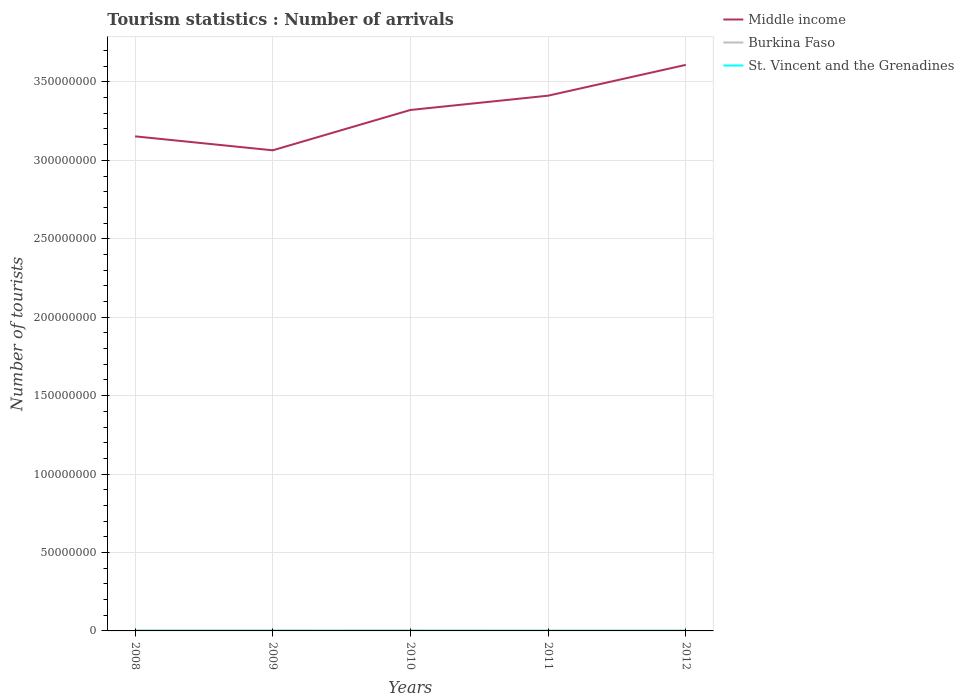Across all years, what is the maximum number of tourist arrivals in Burkina Faso?
Offer a very short reply. 2.37e+05. What is the total number of tourist arrivals in St. Vincent and the Grenadines in the graph?
Your response must be concise. 3000. What is the difference between the highest and the second highest number of tourist arrivals in St. Vincent and the Grenadines?
Offer a very short reply. 1.20e+04. Is the number of tourist arrivals in Middle income strictly greater than the number of tourist arrivals in St. Vincent and the Grenadines over the years?
Give a very brief answer. No. How many lines are there?
Your answer should be very brief. 3. How many years are there in the graph?
Your answer should be very brief. 5. What is the difference between two consecutive major ticks on the Y-axis?
Your answer should be very brief. 5.00e+07. Are the values on the major ticks of Y-axis written in scientific E-notation?
Give a very brief answer. No. Does the graph contain any zero values?
Your answer should be compact. No. What is the title of the graph?
Offer a terse response. Tourism statistics : Number of arrivals. Does "Australia" appear as one of the legend labels in the graph?
Make the answer very short. No. What is the label or title of the X-axis?
Offer a very short reply. Years. What is the label or title of the Y-axis?
Keep it short and to the point. Number of tourists. What is the Number of tourists in Middle income in 2008?
Your answer should be very brief. 3.15e+08. What is the Number of tourists in Burkina Faso in 2008?
Your answer should be very brief. 2.72e+05. What is the Number of tourists of St. Vincent and the Grenadines in 2008?
Make the answer very short. 8.40e+04. What is the Number of tourists of Middle income in 2009?
Provide a short and direct response. 3.06e+08. What is the Number of tourists in Burkina Faso in 2009?
Your answer should be very brief. 2.69e+05. What is the Number of tourists of St. Vincent and the Grenadines in 2009?
Make the answer very short. 7.50e+04. What is the Number of tourists of Middle income in 2010?
Offer a terse response. 3.32e+08. What is the Number of tourists in Burkina Faso in 2010?
Offer a terse response. 2.74e+05. What is the Number of tourists of St. Vincent and the Grenadines in 2010?
Offer a very short reply. 7.20e+04. What is the Number of tourists in Middle income in 2011?
Ensure brevity in your answer.  3.41e+08. What is the Number of tourists in Burkina Faso in 2011?
Offer a terse response. 2.38e+05. What is the Number of tourists in St. Vincent and the Grenadines in 2011?
Your answer should be very brief. 7.40e+04. What is the Number of tourists in Middle income in 2012?
Offer a very short reply. 3.61e+08. What is the Number of tourists of Burkina Faso in 2012?
Make the answer very short. 2.37e+05. What is the Number of tourists in St. Vincent and the Grenadines in 2012?
Your answer should be very brief. 7.40e+04. Across all years, what is the maximum Number of tourists in Middle income?
Your response must be concise. 3.61e+08. Across all years, what is the maximum Number of tourists in Burkina Faso?
Provide a short and direct response. 2.74e+05. Across all years, what is the maximum Number of tourists in St. Vincent and the Grenadines?
Give a very brief answer. 8.40e+04. Across all years, what is the minimum Number of tourists of Middle income?
Provide a succinct answer. 3.06e+08. Across all years, what is the minimum Number of tourists of Burkina Faso?
Your response must be concise. 2.37e+05. Across all years, what is the minimum Number of tourists in St. Vincent and the Grenadines?
Provide a succinct answer. 7.20e+04. What is the total Number of tourists of Middle income in the graph?
Ensure brevity in your answer.  1.66e+09. What is the total Number of tourists of Burkina Faso in the graph?
Ensure brevity in your answer.  1.29e+06. What is the total Number of tourists of St. Vincent and the Grenadines in the graph?
Ensure brevity in your answer.  3.79e+05. What is the difference between the Number of tourists in Middle income in 2008 and that in 2009?
Your answer should be compact. 8.90e+06. What is the difference between the Number of tourists of Burkina Faso in 2008 and that in 2009?
Provide a succinct answer. 3000. What is the difference between the Number of tourists in St. Vincent and the Grenadines in 2008 and that in 2009?
Your answer should be very brief. 9000. What is the difference between the Number of tourists of Middle income in 2008 and that in 2010?
Your answer should be very brief. -1.68e+07. What is the difference between the Number of tourists of Burkina Faso in 2008 and that in 2010?
Offer a terse response. -2000. What is the difference between the Number of tourists of St. Vincent and the Grenadines in 2008 and that in 2010?
Your answer should be compact. 1.20e+04. What is the difference between the Number of tourists in Middle income in 2008 and that in 2011?
Your answer should be compact. -2.59e+07. What is the difference between the Number of tourists of Burkina Faso in 2008 and that in 2011?
Provide a short and direct response. 3.40e+04. What is the difference between the Number of tourists of Middle income in 2008 and that in 2012?
Keep it short and to the point. -4.56e+07. What is the difference between the Number of tourists in Burkina Faso in 2008 and that in 2012?
Offer a terse response. 3.50e+04. What is the difference between the Number of tourists in Middle income in 2009 and that in 2010?
Give a very brief answer. -2.57e+07. What is the difference between the Number of tourists of Burkina Faso in 2009 and that in 2010?
Offer a terse response. -5000. What is the difference between the Number of tourists in St. Vincent and the Grenadines in 2009 and that in 2010?
Make the answer very short. 3000. What is the difference between the Number of tourists of Middle income in 2009 and that in 2011?
Your response must be concise. -3.48e+07. What is the difference between the Number of tourists in Burkina Faso in 2009 and that in 2011?
Keep it short and to the point. 3.10e+04. What is the difference between the Number of tourists of St. Vincent and the Grenadines in 2009 and that in 2011?
Your answer should be very brief. 1000. What is the difference between the Number of tourists of Middle income in 2009 and that in 2012?
Keep it short and to the point. -5.45e+07. What is the difference between the Number of tourists of Burkina Faso in 2009 and that in 2012?
Keep it short and to the point. 3.20e+04. What is the difference between the Number of tourists in St. Vincent and the Grenadines in 2009 and that in 2012?
Give a very brief answer. 1000. What is the difference between the Number of tourists in Middle income in 2010 and that in 2011?
Keep it short and to the point. -9.11e+06. What is the difference between the Number of tourists in Burkina Faso in 2010 and that in 2011?
Offer a very short reply. 3.60e+04. What is the difference between the Number of tourists in St. Vincent and the Grenadines in 2010 and that in 2011?
Your answer should be compact. -2000. What is the difference between the Number of tourists of Middle income in 2010 and that in 2012?
Offer a very short reply. -2.88e+07. What is the difference between the Number of tourists of Burkina Faso in 2010 and that in 2012?
Give a very brief answer. 3.70e+04. What is the difference between the Number of tourists in St. Vincent and the Grenadines in 2010 and that in 2012?
Offer a terse response. -2000. What is the difference between the Number of tourists in Middle income in 2011 and that in 2012?
Offer a very short reply. -1.96e+07. What is the difference between the Number of tourists of St. Vincent and the Grenadines in 2011 and that in 2012?
Ensure brevity in your answer.  0. What is the difference between the Number of tourists of Middle income in 2008 and the Number of tourists of Burkina Faso in 2009?
Keep it short and to the point. 3.15e+08. What is the difference between the Number of tourists of Middle income in 2008 and the Number of tourists of St. Vincent and the Grenadines in 2009?
Offer a very short reply. 3.15e+08. What is the difference between the Number of tourists of Burkina Faso in 2008 and the Number of tourists of St. Vincent and the Grenadines in 2009?
Your answer should be compact. 1.97e+05. What is the difference between the Number of tourists in Middle income in 2008 and the Number of tourists in Burkina Faso in 2010?
Your answer should be compact. 3.15e+08. What is the difference between the Number of tourists in Middle income in 2008 and the Number of tourists in St. Vincent and the Grenadines in 2010?
Offer a terse response. 3.15e+08. What is the difference between the Number of tourists of Burkina Faso in 2008 and the Number of tourists of St. Vincent and the Grenadines in 2010?
Keep it short and to the point. 2.00e+05. What is the difference between the Number of tourists in Middle income in 2008 and the Number of tourists in Burkina Faso in 2011?
Your answer should be compact. 3.15e+08. What is the difference between the Number of tourists in Middle income in 2008 and the Number of tourists in St. Vincent and the Grenadines in 2011?
Make the answer very short. 3.15e+08. What is the difference between the Number of tourists of Burkina Faso in 2008 and the Number of tourists of St. Vincent and the Grenadines in 2011?
Offer a very short reply. 1.98e+05. What is the difference between the Number of tourists of Middle income in 2008 and the Number of tourists of Burkina Faso in 2012?
Your answer should be compact. 3.15e+08. What is the difference between the Number of tourists of Middle income in 2008 and the Number of tourists of St. Vincent and the Grenadines in 2012?
Make the answer very short. 3.15e+08. What is the difference between the Number of tourists in Burkina Faso in 2008 and the Number of tourists in St. Vincent and the Grenadines in 2012?
Offer a very short reply. 1.98e+05. What is the difference between the Number of tourists of Middle income in 2009 and the Number of tourists of Burkina Faso in 2010?
Provide a short and direct response. 3.06e+08. What is the difference between the Number of tourists in Middle income in 2009 and the Number of tourists in St. Vincent and the Grenadines in 2010?
Provide a succinct answer. 3.06e+08. What is the difference between the Number of tourists of Burkina Faso in 2009 and the Number of tourists of St. Vincent and the Grenadines in 2010?
Give a very brief answer. 1.97e+05. What is the difference between the Number of tourists in Middle income in 2009 and the Number of tourists in Burkina Faso in 2011?
Your answer should be very brief. 3.06e+08. What is the difference between the Number of tourists of Middle income in 2009 and the Number of tourists of St. Vincent and the Grenadines in 2011?
Your answer should be very brief. 3.06e+08. What is the difference between the Number of tourists in Burkina Faso in 2009 and the Number of tourists in St. Vincent and the Grenadines in 2011?
Provide a succinct answer. 1.95e+05. What is the difference between the Number of tourists of Middle income in 2009 and the Number of tourists of Burkina Faso in 2012?
Offer a very short reply. 3.06e+08. What is the difference between the Number of tourists in Middle income in 2009 and the Number of tourists in St. Vincent and the Grenadines in 2012?
Your response must be concise. 3.06e+08. What is the difference between the Number of tourists in Burkina Faso in 2009 and the Number of tourists in St. Vincent and the Grenadines in 2012?
Provide a short and direct response. 1.95e+05. What is the difference between the Number of tourists of Middle income in 2010 and the Number of tourists of Burkina Faso in 2011?
Your answer should be very brief. 3.32e+08. What is the difference between the Number of tourists in Middle income in 2010 and the Number of tourists in St. Vincent and the Grenadines in 2011?
Ensure brevity in your answer.  3.32e+08. What is the difference between the Number of tourists of Burkina Faso in 2010 and the Number of tourists of St. Vincent and the Grenadines in 2011?
Ensure brevity in your answer.  2.00e+05. What is the difference between the Number of tourists in Middle income in 2010 and the Number of tourists in Burkina Faso in 2012?
Ensure brevity in your answer.  3.32e+08. What is the difference between the Number of tourists in Middle income in 2010 and the Number of tourists in St. Vincent and the Grenadines in 2012?
Your answer should be very brief. 3.32e+08. What is the difference between the Number of tourists of Middle income in 2011 and the Number of tourists of Burkina Faso in 2012?
Your answer should be compact. 3.41e+08. What is the difference between the Number of tourists of Middle income in 2011 and the Number of tourists of St. Vincent and the Grenadines in 2012?
Make the answer very short. 3.41e+08. What is the difference between the Number of tourists in Burkina Faso in 2011 and the Number of tourists in St. Vincent and the Grenadines in 2012?
Make the answer very short. 1.64e+05. What is the average Number of tourists of Middle income per year?
Keep it short and to the point. 3.31e+08. What is the average Number of tourists of Burkina Faso per year?
Ensure brevity in your answer.  2.58e+05. What is the average Number of tourists of St. Vincent and the Grenadines per year?
Your answer should be very brief. 7.58e+04. In the year 2008, what is the difference between the Number of tourists in Middle income and Number of tourists in Burkina Faso?
Offer a terse response. 3.15e+08. In the year 2008, what is the difference between the Number of tourists in Middle income and Number of tourists in St. Vincent and the Grenadines?
Keep it short and to the point. 3.15e+08. In the year 2008, what is the difference between the Number of tourists in Burkina Faso and Number of tourists in St. Vincent and the Grenadines?
Your answer should be very brief. 1.88e+05. In the year 2009, what is the difference between the Number of tourists in Middle income and Number of tourists in Burkina Faso?
Your answer should be compact. 3.06e+08. In the year 2009, what is the difference between the Number of tourists in Middle income and Number of tourists in St. Vincent and the Grenadines?
Your response must be concise. 3.06e+08. In the year 2009, what is the difference between the Number of tourists in Burkina Faso and Number of tourists in St. Vincent and the Grenadines?
Give a very brief answer. 1.94e+05. In the year 2010, what is the difference between the Number of tourists in Middle income and Number of tourists in Burkina Faso?
Make the answer very short. 3.32e+08. In the year 2010, what is the difference between the Number of tourists in Middle income and Number of tourists in St. Vincent and the Grenadines?
Your response must be concise. 3.32e+08. In the year 2010, what is the difference between the Number of tourists of Burkina Faso and Number of tourists of St. Vincent and the Grenadines?
Ensure brevity in your answer.  2.02e+05. In the year 2011, what is the difference between the Number of tourists of Middle income and Number of tourists of Burkina Faso?
Make the answer very short. 3.41e+08. In the year 2011, what is the difference between the Number of tourists in Middle income and Number of tourists in St. Vincent and the Grenadines?
Ensure brevity in your answer.  3.41e+08. In the year 2011, what is the difference between the Number of tourists of Burkina Faso and Number of tourists of St. Vincent and the Grenadines?
Make the answer very short. 1.64e+05. In the year 2012, what is the difference between the Number of tourists of Middle income and Number of tourists of Burkina Faso?
Offer a very short reply. 3.61e+08. In the year 2012, what is the difference between the Number of tourists in Middle income and Number of tourists in St. Vincent and the Grenadines?
Ensure brevity in your answer.  3.61e+08. In the year 2012, what is the difference between the Number of tourists in Burkina Faso and Number of tourists in St. Vincent and the Grenadines?
Give a very brief answer. 1.63e+05. What is the ratio of the Number of tourists in Burkina Faso in 2008 to that in 2009?
Provide a short and direct response. 1.01. What is the ratio of the Number of tourists in St. Vincent and the Grenadines in 2008 to that in 2009?
Provide a succinct answer. 1.12. What is the ratio of the Number of tourists of Middle income in 2008 to that in 2010?
Offer a terse response. 0.95. What is the ratio of the Number of tourists of Burkina Faso in 2008 to that in 2010?
Make the answer very short. 0.99. What is the ratio of the Number of tourists in Middle income in 2008 to that in 2011?
Offer a terse response. 0.92. What is the ratio of the Number of tourists of Burkina Faso in 2008 to that in 2011?
Ensure brevity in your answer.  1.14. What is the ratio of the Number of tourists of St. Vincent and the Grenadines in 2008 to that in 2011?
Give a very brief answer. 1.14. What is the ratio of the Number of tourists of Middle income in 2008 to that in 2012?
Ensure brevity in your answer.  0.87. What is the ratio of the Number of tourists in Burkina Faso in 2008 to that in 2012?
Provide a short and direct response. 1.15. What is the ratio of the Number of tourists in St. Vincent and the Grenadines in 2008 to that in 2012?
Provide a short and direct response. 1.14. What is the ratio of the Number of tourists of Middle income in 2009 to that in 2010?
Keep it short and to the point. 0.92. What is the ratio of the Number of tourists of Burkina Faso in 2009 to that in 2010?
Your answer should be compact. 0.98. What is the ratio of the Number of tourists in St. Vincent and the Grenadines in 2009 to that in 2010?
Your response must be concise. 1.04. What is the ratio of the Number of tourists of Middle income in 2009 to that in 2011?
Give a very brief answer. 0.9. What is the ratio of the Number of tourists in Burkina Faso in 2009 to that in 2011?
Offer a terse response. 1.13. What is the ratio of the Number of tourists in St. Vincent and the Grenadines in 2009 to that in 2011?
Offer a very short reply. 1.01. What is the ratio of the Number of tourists of Middle income in 2009 to that in 2012?
Offer a terse response. 0.85. What is the ratio of the Number of tourists in Burkina Faso in 2009 to that in 2012?
Provide a succinct answer. 1.14. What is the ratio of the Number of tourists in St. Vincent and the Grenadines in 2009 to that in 2012?
Your response must be concise. 1.01. What is the ratio of the Number of tourists in Middle income in 2010 to that in 2011?
Your answer should be very brief. 0.97. What is the ratio of the Number of tourists in Burkina Faso in 2010 to that in 2011?
Keep it short and to the point. 1.15. What is the ratio of the Number of tourists in Middle income in 2010 to that in 2012?
Provide a succinct answer. 0.92. What is the ratio of the Number of tourists of Burkina Faso in 2010 to that in 2012?
Offer a very short reply. 1.16. What is the ratio of the Number of tourists of St. Vincent and the Grenadines in 2010 to that in 2012?
Your answer should be very brief. 0.97. What is the ratio of the Number of tourists in Middle income in 2011 to that in 2012?
Your answer should be compact. 0.95. What is the ratio of the Number of tourists in Burkina Faso in 2011 to that in 2012?
Give a very brief answer. 1. What is the difference between the highest and the second highest Number of tourists in Middle income?
Provide a succinct answer. 1.96e+07. What is the difference between the highest and the second highest Number of tourists of Burkina Faso?
Make the answer very short. 2000. What is the difference between the highest and the second highest Number of tourists of St. Vincent and the Grenadines?
Ensure brevity in your answer.  9000. What is the difference between the highest and the lowest Number of tourists of Middle income?
Offer a very short reply. 5.45e+07. What is the difference between the highest and the lowest Number of tourists of Burkina Faso?
Your response must be concise. 3.70e+04. What is the difference between the highest and the lowest Number of tourists in St. Vincent and the Grenadines?
Keep it short and to the point. 1.20e+04. 